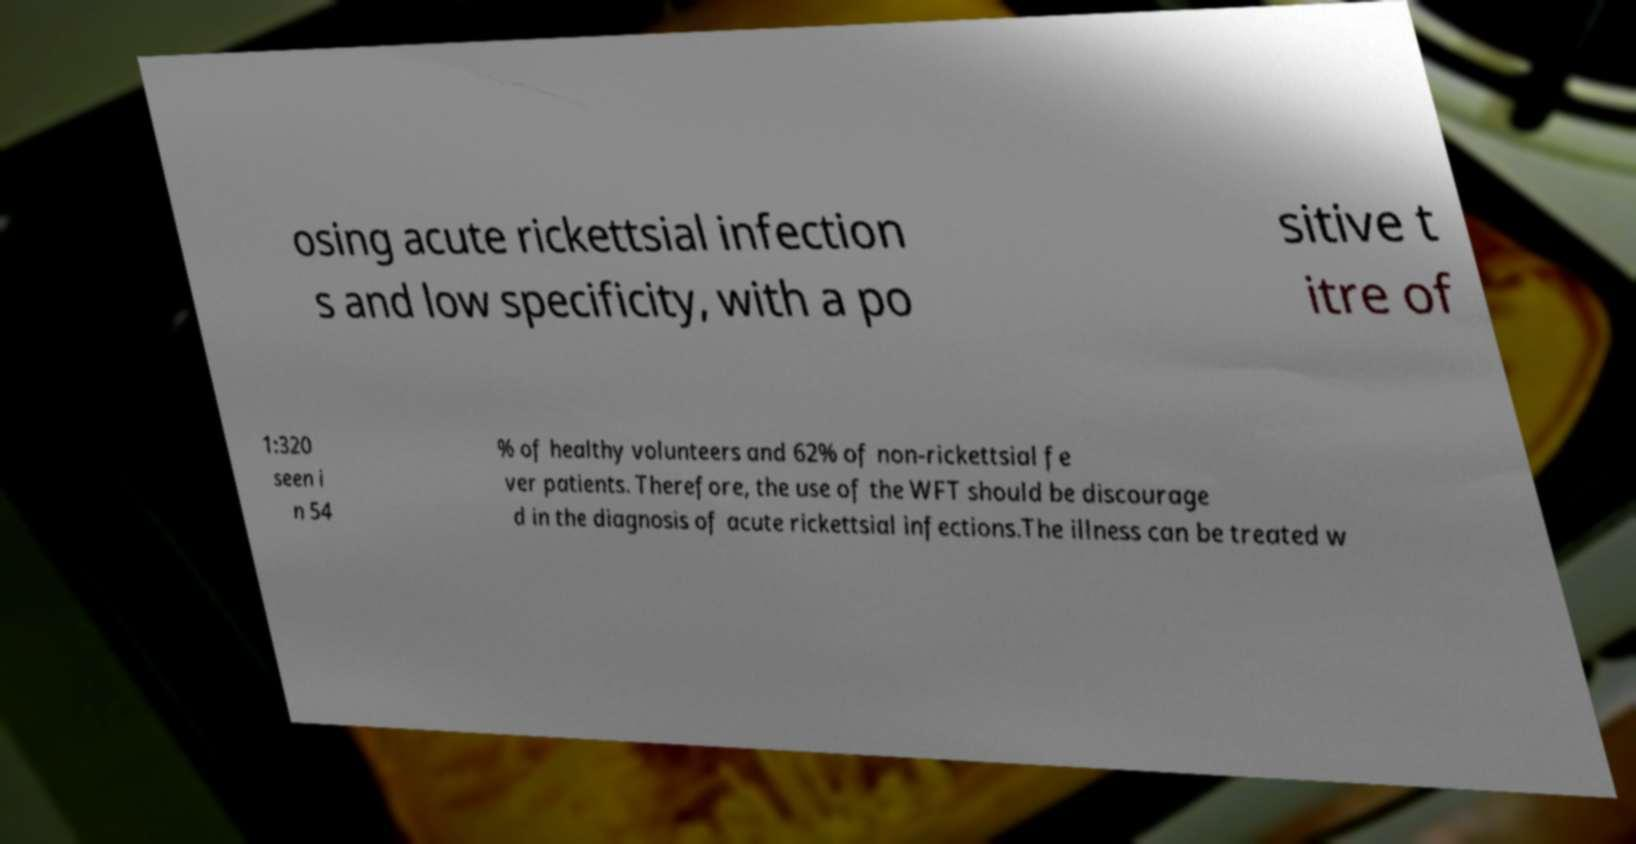Please read and relay the text visible in this image. What does it say? osing acute rickettsial infection s and low specificity, with a po sitive t itre of 1:320 seen i n 54 % of healthy volunteers and 62% of non-rickettsial fe ver patients. Therefore, the use of the WFT should be discourage d in the diagnosis of acute rickettsial infections.The illness can be treated w 